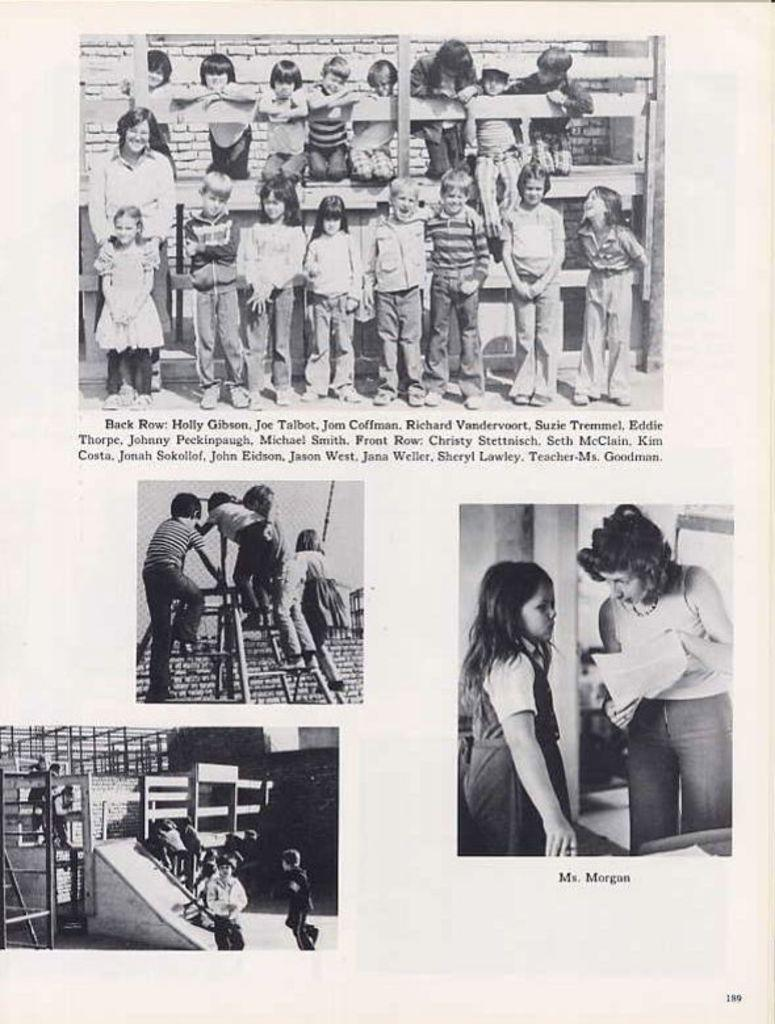What is present in the image that has a design or message? There is a poster in the image that has a design or message. What else can be seen in the image besides the poster? There are people in the image. Can you describe the writing on the poster? The facts provided do not specify the content of the writing on the poster. Is there a bike visible in the image? There is no mention of a bike in the provided facts, so it cannot be determined if one is present in the image. 